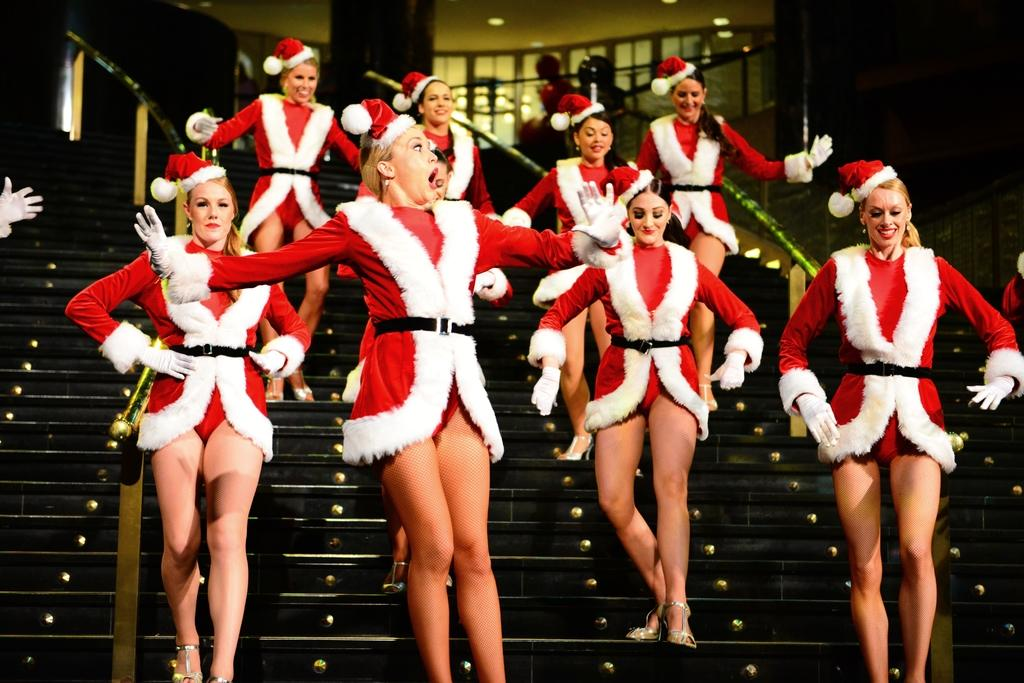Who is present in the image? There are women in the image. What are the women doing in the image? The women are walking on steps. What is the emotional expression of the women in the image? The women are smiling. Reasoning: Let' Let's think step by step in order to produce the conversation. We start by identifying the main subjects in the image, which are the women. Then, we describe their actions, which are walking on steps. Finally, we mention their emotional state, which is smiling. Each question is designed to elicit a specific detail about the image that is known from the provided facts. Absurd Question/Answer: What type of rings can be seen on the women's fingers in the image? There are no rings visible on the women's fingers in the image. What is the tendency of the women to do in the image? The provided facts do not mention any specific tendency of the women in the image. 